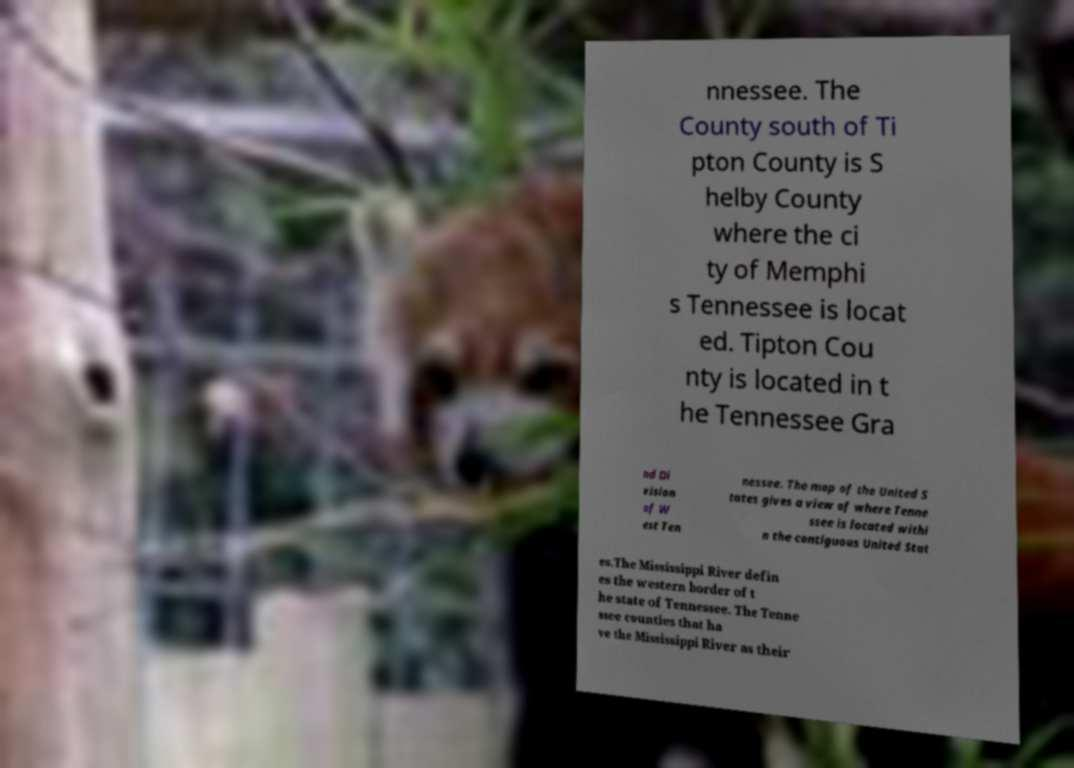What messages or text are displayed in this image? I need them in a readable, typed format. nnessee. The County south of Ti pton County is S helby County where the ci ty of Memphi s Tennessee is locat ed. Tipton Cou nty is located in t he Tennessee Gra nd Di vision of W est Ten nessee. The map of the United S tates gives a view of where Tenne ssee is located withi n the contiguous United Stat es.The Mississippi River defin es the western border of t he state of Tennessee. The Tenne ssee counties that ha ve the Mississippi River as their 